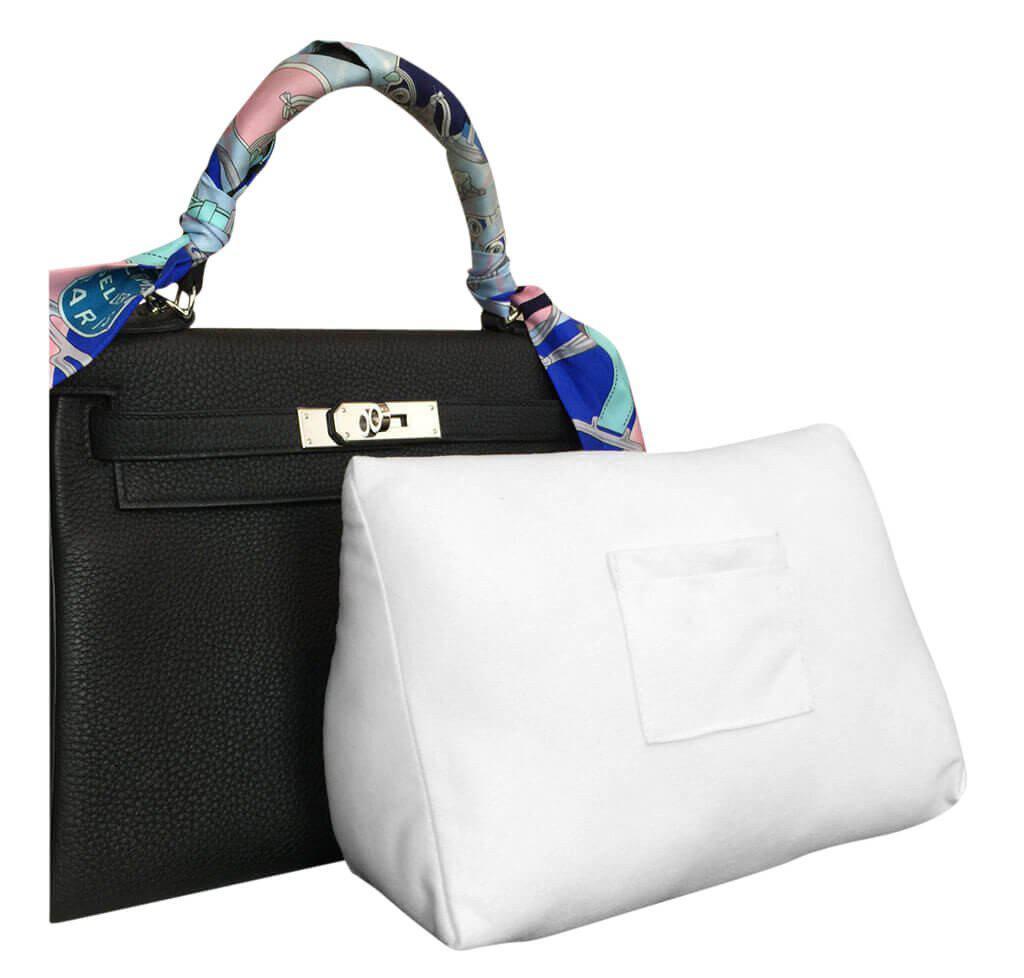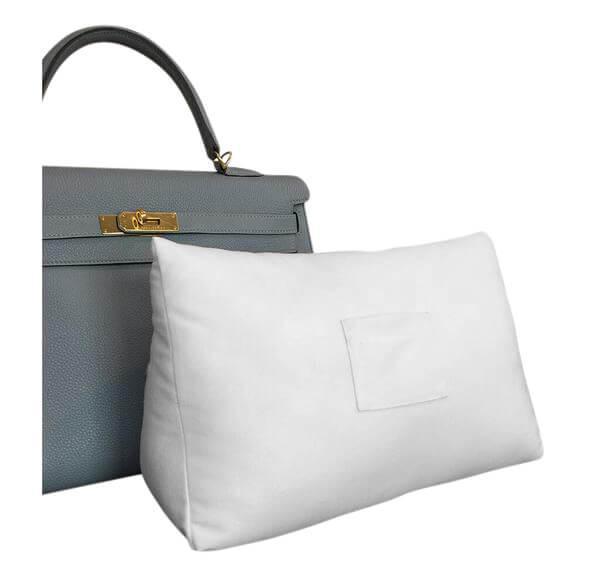The first image is the image on the left, the second image is the image on the right. Evaluate the accuracy of this statement regarding the images: "The purse in the left image is predominately blue.". Is it true? Answer yes or no. No. The first image is the image on the left, the second image is the image on the right. Analyze the images presented: Is the assertion "The bags in the left and right images are displayed in the same position." valid? Answer yes or no. Yes. 